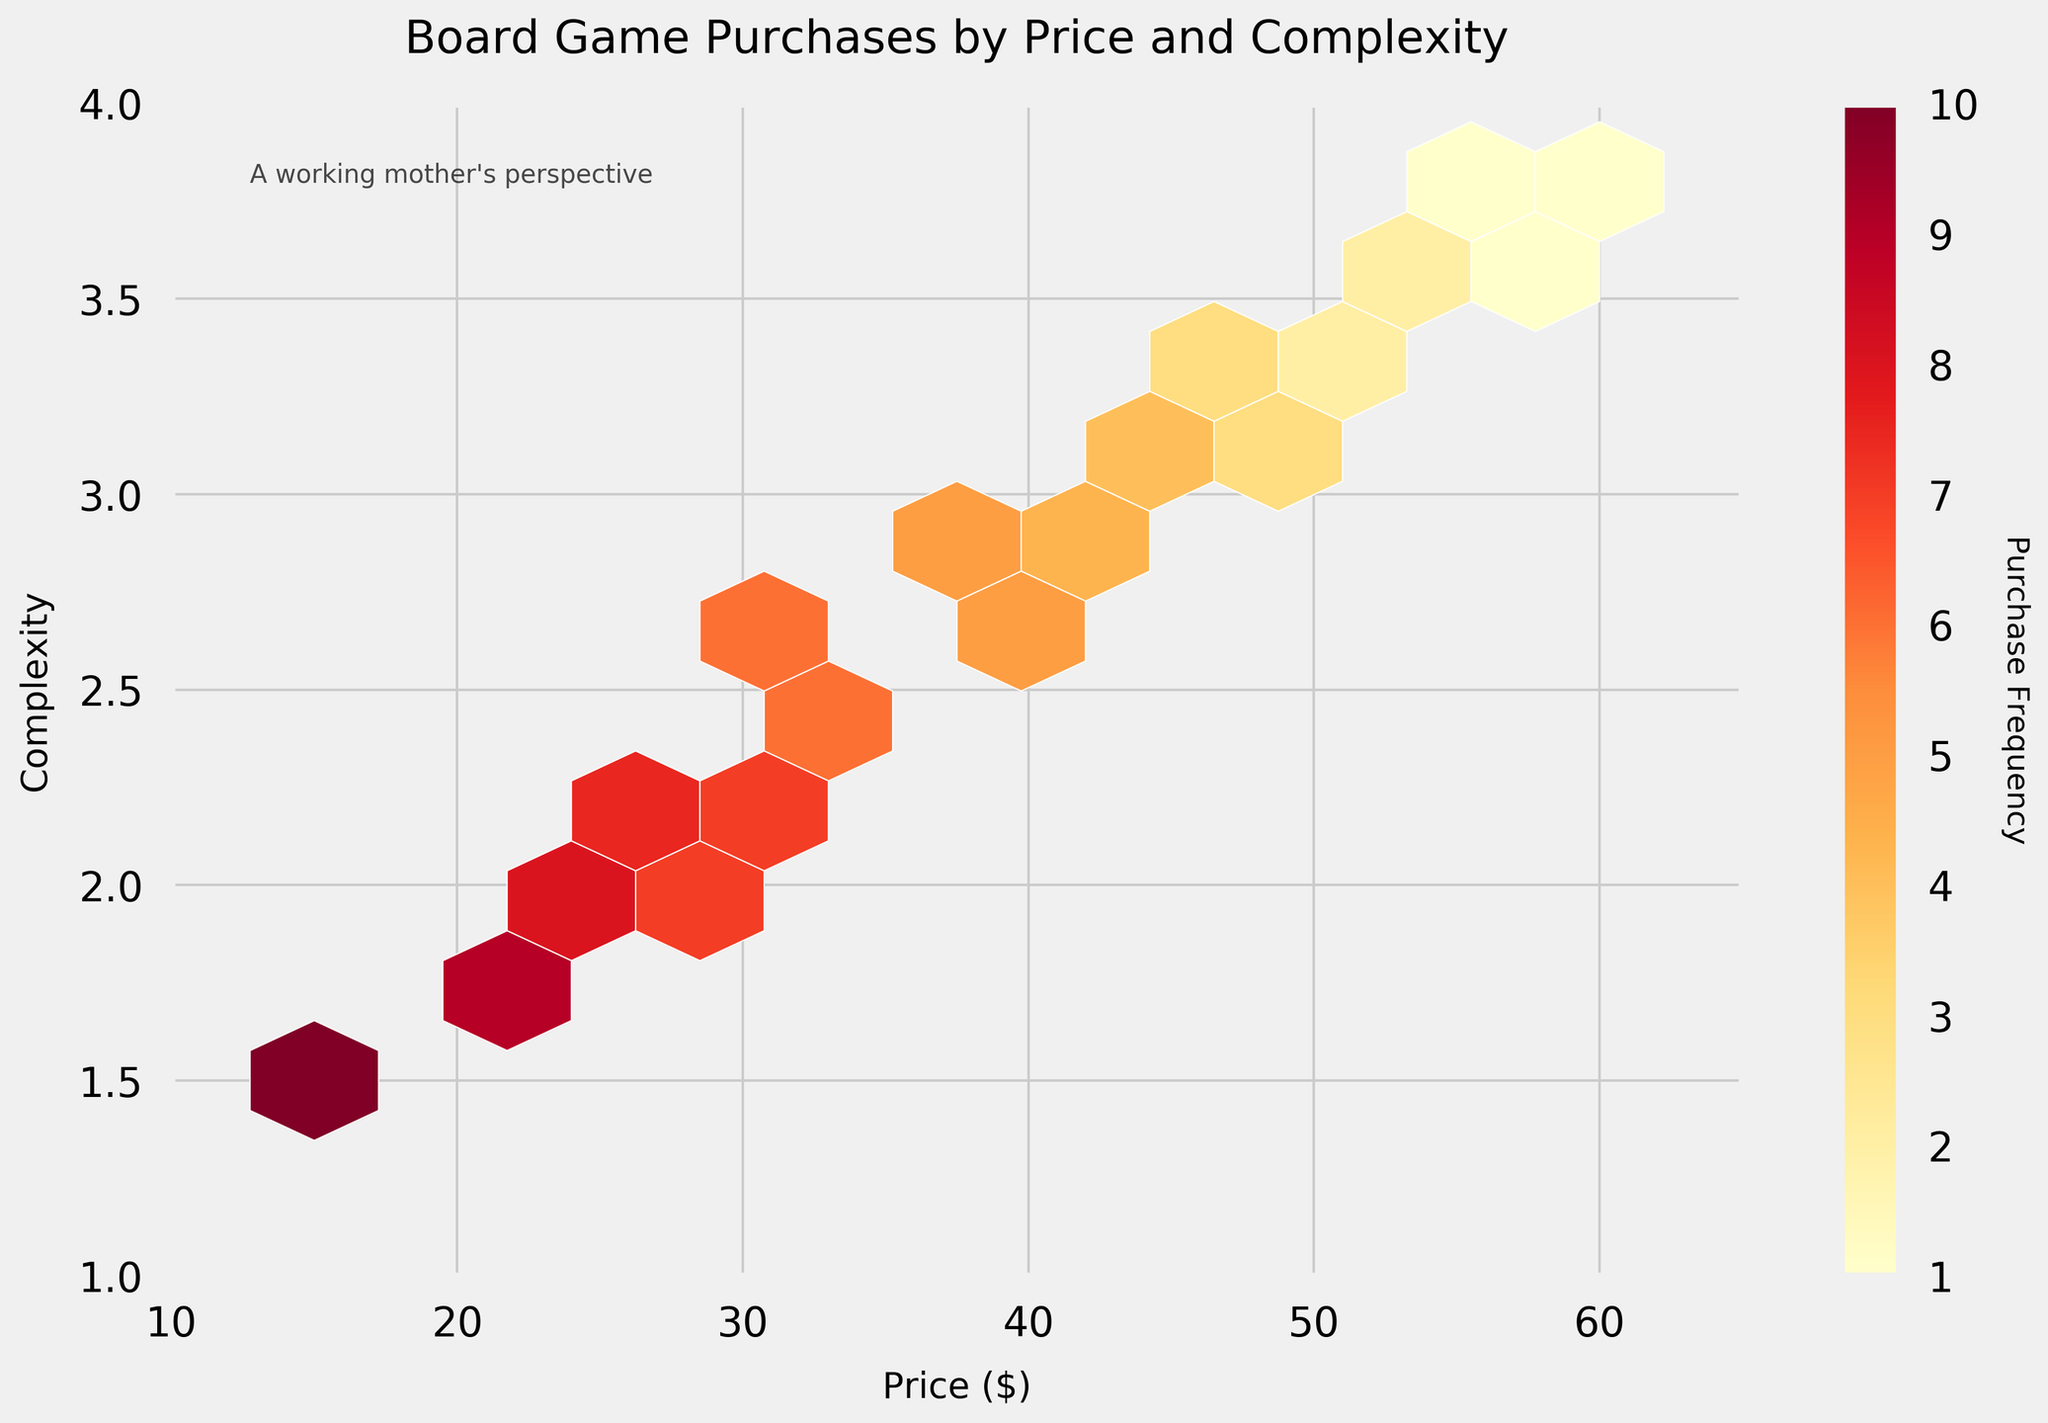Which price and complexity range shows the highest frequency of board game purchases? By examining the color intensity in the hexbin plot, the darkest hexagon indicates the highest frequency. To find the range, look at the corresponding x-axis (Price) and y-axis (Complexity) values for this hexagon. The highest frequency is around Price $15 and Complexity 1.5.
Answer: Price $15, Complexity 1.5 What is the title of the hexbin plot? The title of the plot is usually located at the top of the figure in larger and bold font. The title reads "Board Game Purchases by Price and Complexity."
Answer: Board Game Purchases by Price and Complexity Which price range appears to be less popular, judging by lower purchase frequencies? Search for the lighter hexagons, which indicate lower frequencies, on the hexbin plot. The lightest colors appear around the higher price ranges like $55-$60.
Answer: $55-$60 Is there a trend between price and complexity with respect to board game purchases? By observing the overall pattern and the distribution of hexagons in the plot, it suggests that as the price increases, the complexity also tends to increase. However, the purchase frequency decreases as both metrics increase.
Answer: Higher price and complexity, lower purchase frequency How is the color used in the plot to indicate purchase frequency? The plot uses a color gradient from light to dark to represent frequencies. The lighter colors indicate lower frequencies, and the darker colors indicate higher frequencies. This is visually represented in the plot's legend.
Answer: Light to dark gradient What does the color bar represent in the plot? The color bar usually represents a key to the color gradient used in the plot. Here, it is labeled "Purchase Frequency" and shows how the colors correspond to different frequency values.
Answer: Purchase Frequency How does the complexity of board games purchased vary with price according to the plot? The plot's hexagon distribution shows that as the price range increases, the corresponding complexity also tends to be higher. Lower-priced games are less complex, while higher-priced games are more complex.
Answer: Higher price, higher complexity What does the text note at the top left corner of the plot signify? The plot contains a text note in the top left corner that provides contextual information or an additional perspective. It states "A working mother's perspective," indicating the viewer's or data collector's viewpoint.
Answer: A working mother's perspective Which price range has the most varied complexity levels according to the plot? Identify the price ranges with hexagons spread across a wider range of complexity levels. Prices between $20 and $40 exhibit varied complexity from lower to middle levels.
Answer: $20-$40 What is the typical complexity for board games priced at $50? Locate the hexagons corresponding to a price of $50 on the plot and note the associated complexity value. The typical complexity for games priced at $50 is around 3.2.
Answer: 3.2 